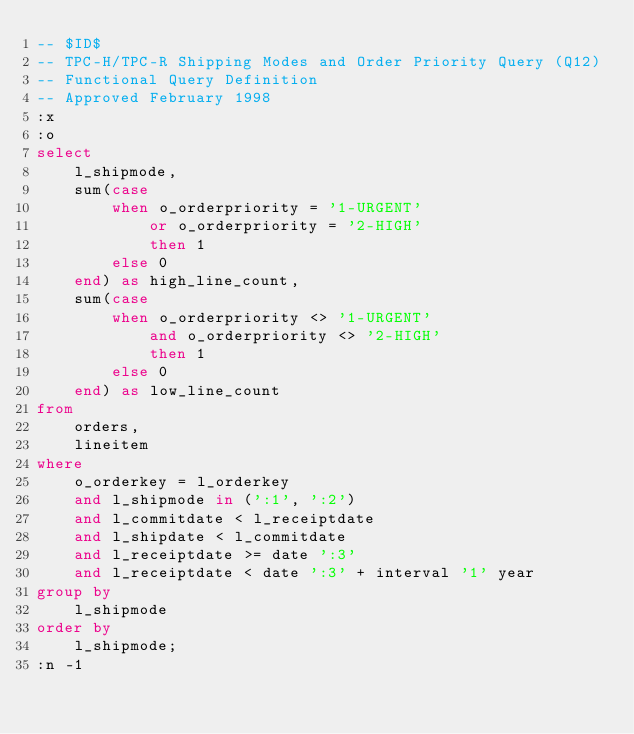Convert code to text. <code><loc_0><loc_0><loc_500><loc_500><_SQL_>-- $ID$
-- TPC-H/TPC-R Shipping Modes and Order Priority Query (Q12)
-- Functional Query Definition
-- Approved February 1998
:x
:o
select
	l_shipmode,
	sum(case
		when o_orderpriority = '1-URGENT'
			or o_orderpriority = '2-HIGH'
			then 1
		else 0
	end) as high_line_count,
	sum(case
		when o_orderpriority <> '1-URGENT'
			and o_orderpriority <> '2-HIGH'
			then 1
		else 0
	end) as low_line_count
from
	orders,
	lineitem
where
	o_orderkey = l_orderkey
	and l_shipmode in (':1', ':2')
	and l_commitdate < l_receiptdate
	and l_shipdate < l_commitdate
	and l_receiptdate >= date ':3'
	and l_receiptdate < date ':3' + interval '1' year
group by
	l_shipmode
order by
	l_shipmode;
:n -1
</code> 